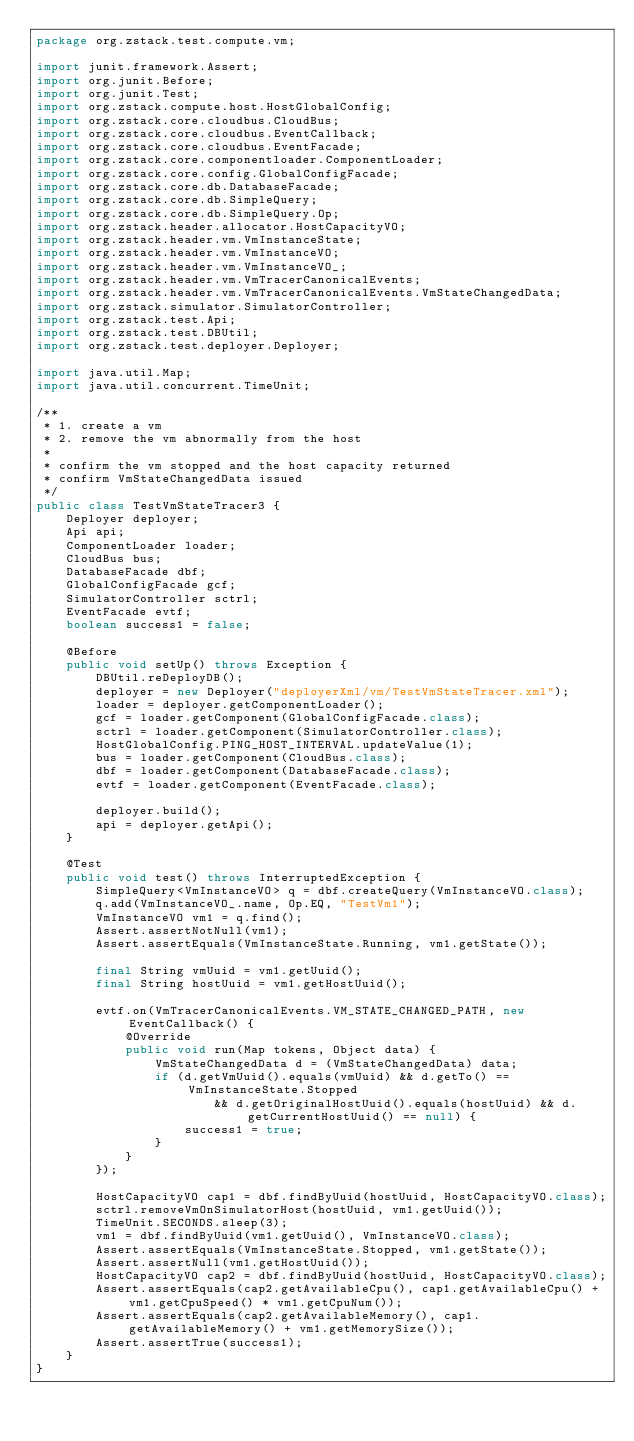Convert code to text. <code><loc_0><loc_0><loc_500><loc_500><_Java_>package org.zstack.test.compute.vm;

import junit.framework.Assert;
import org.junit.Before;
import org.junit.Test;
import org.zstack.compute.host.HostGlobalConfig;
import org.zstack.core.cloudbus.CloudBus;
import org.zstack.core.cloudbus.EventCallback;
import org.zstack.core.cloudbus.EventFacade;
import org.zstack.core.componentloader.ComponentLoader;
import org.zstack.core.config.GlobalConfigFacade;
import org.zstack.core.db.DatabaseFacade;
import org.zstack.core.db.SimpleQuery;
import org.zstack.core.db.SimpleQuery.Op;
import org.zstack.header.allocator.HostCapacityVO;
import org.zstack.header.vm.VmInstanceState;
import org.zstack.header.vm.VmInstanceVO;
import org.zstack.header.vm.VmInstanceVO_;
import org.zstack.header.vm.VmTracerCanonicalEvents;
import org.zstack.header.vm.VmTracerCanonicalEvents.VmStateChangedData;
import org.zstack.simulator.SimulatorController;
import org.zstack.test.Api;
import org.zstack.test.DBUtil;
import org.zstack.test.deployer.Deployer;

import java.util.Map;
import java.util.concurrent.TimeUnit;

/**
 * 1. create a vm
 * 2. remove the vm abnormally from the host
 *
 * confirm the vm stopped and the host capacity returned
 * confirm VmStateChangedData issued
 */
public class TestVmStateTracer3 {
    Deployer deployer;
    Api api;
    ComponentLoader loader;
    CloudBus bus;
    DatabaseFacade dbf;
    GlobalConfigFacade gcf;
    SimulatorController sctrl;
    EventFacade evtf;
    boolean success1 = false;

    @Before
    public void setUp() throws Exception {
        DBUtil.reDeployDB();
        deployer = new Deployer("deployerXml/vm/TestVmStateTracer.xml");
        loader = deployer.getComponentLoader();
        gcf = loader.getComponent(GlobalConfigFacade.class);
        sctrl = loader.getComponent(SimulatorController.class);
        HostGlobalConfig.PING_HOST_INTERVAL.updateValue(1);
        bus = loader.getComponent(CloudBus.class);
        dbf = loader.getComponent(DatabaseFacade.class);
        evtf = loader.getComponent(EventFacade.class);
        
        deployer.build();
        api = deployer.getApi();
    }
    
    @Test
    public void test() throws InterruptedException {
        SimpleQuery<VmInstanceVO> q = dbf.createQuery(VmInstanceVO.class);
        q.add(VmInstanceVO_.name, Op.EQ, "TestVm1");
        VmInstanceVO vm1 = q.find();
        Assert.assertNotNull(vm1);
        Assert.assertEquals(VmInstanceState.Running, vm1.getState());

        final String vmUuid = vm1.getUuid();
        final String hostUuid = vm1.getHostUuid();

        evtf.on(VmTracerCanonicalEvents.VM_STATE_CHANGED_PATH, new EventCallback() {
            @Override
            public void run(Map tokens, Object data) {
                VmStateChangedData d = (VmStateChangedData) data;
                if (d.getVmUuid().equals(vmUuid) && d.getTo() == VmInstanceState.Stopped
                        && d.getOriginalHostUuid().equals(hostUuid) && d.getCurrentHostUuid() == null) {
                    success1 = true;
                }
            }
        });

        HostCapacityVO cap1 = dbf.findByUuid(hostUuid, HostCapacityVO.class);
        sctrl.removeVmOnSimulatorHost(hostUuid, vm1.getUuid());
        TimeUnit.SECONDS.sleep(3);
        vm1 = dbf.findByUuid(vm1.getUuid(), VmInstanceVO.class);
        Assert.assertEquals(VmInstanceState.Stopped, vm1.getState());
        Assert.assertNull(vm1.getHostUuid());
        HostCapacityVO cap2 = dbf.findByUuid(hostUuid, HostCapacityVO.class);
        Assert.assertEquals(cap2.getAvailableCpu(), cap1.getAvailableCpu() + vm1.getCpuSpeed() * vm1.getCpuNum());
        Assert.assertEquals(cap2.getAvailableMemory(), cap1.getAvailableMemory() + vm1.getMemorySize());
        Assert.assertTrue(success1);
    }
}
</code> 